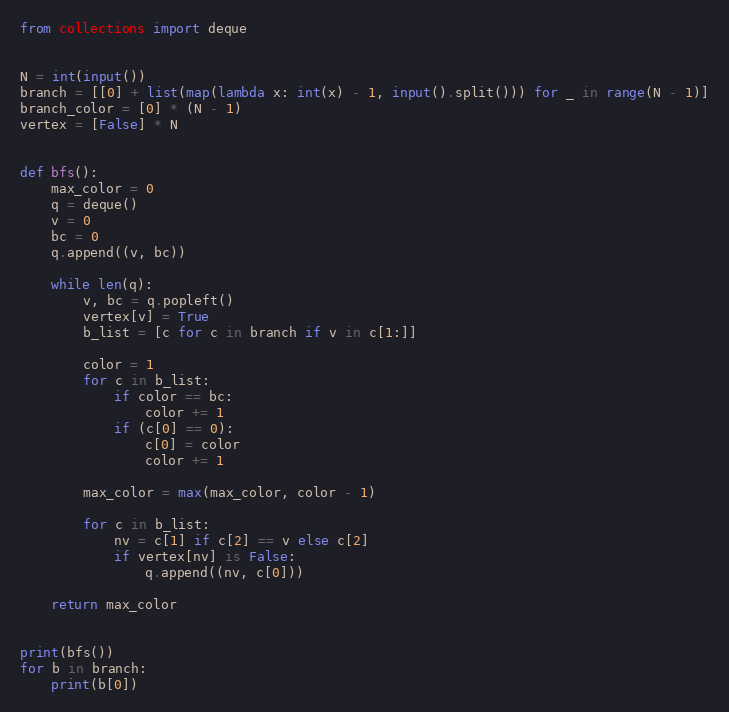<code> <loc_0><loc_0><loc_500><loc_500><_Python_>from collections import deque


N = int(input())
branch = [[0] + list(map(lambda x: int(x) - 1, input().split())) for _ in range(N - 1)]
branch_color = [0] * (N - 1)
vertex = [False] * N


def bfs():
    max_color = 0
    q = deque()
    v = 0
    bc = 0
    q.append((v, bc))

    while len(q):
        v, bc = q.popleft()
        vertex[v] = True
        b_list = [c for c in branch if v in c[1:]]

        color = 1
        for c in b_list:
            if color == bc:
                color += 1
            if (c[0] == 0):
                c[0] = color
                color += 1

        max_color = max(max_color, color - 1)

        for c in b_list:
            nv = c[1] if c[2] == v else c[2]
            if vertex[nv] is False:
                q.append((nv, c[0]))

    return max_color


print(bfs())
for b in branch:
    print(b[0])
</code> 